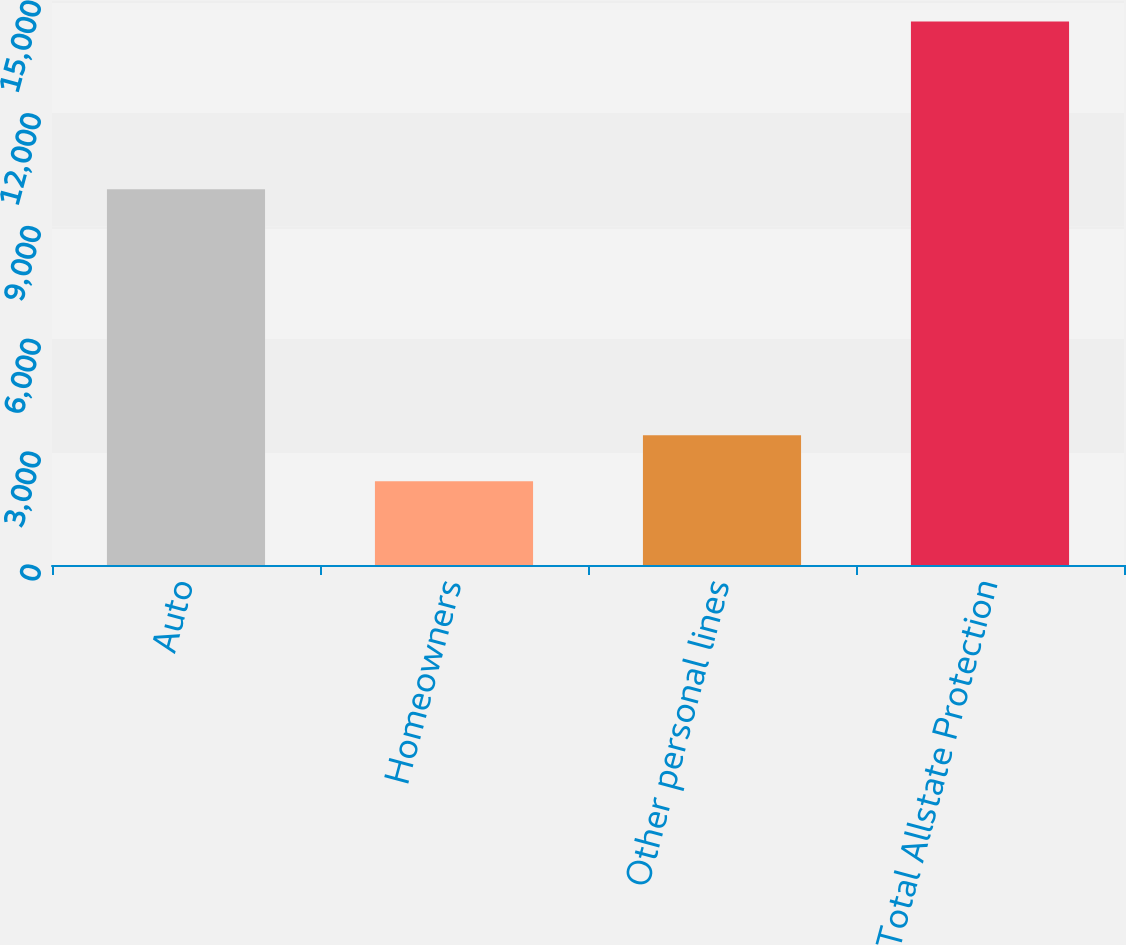<chart> <loc_0><loc_0><loc_500><loc_500><bar_chart><fcel>Auto<fcel>Homeowners<fcel>Other personal lines<fcel>Total Allstate Protection<nl><fcel>9995<fcel>2226<fcel>3449<fcel>14456<nl></chart> 